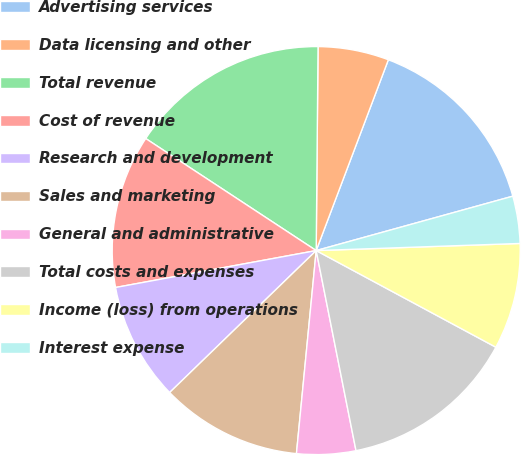Convert chart. <chart><loc_0><loc_0><loc_500><loc_500><pie_chart><fcel>Advertising services<fcel>Data licensing and other<fcel>Total revenue<fcel>Cost of revenue<fcel>Research and development<fcel>Sales and marketing<fcel>General and administrative<fcel>Total costs and expenses<fcel>Income (loss) from operations<fcel>Interest expense<nl><fcel>14.95%<fcel>5.61%<fcel>15.89%<fcel>12.15%<fcel>9.35%<fcel>11.21%<fcel>4.67%<fcel>14.02%<fcel>8.41%<fcel>3.74%<nl></chart> 